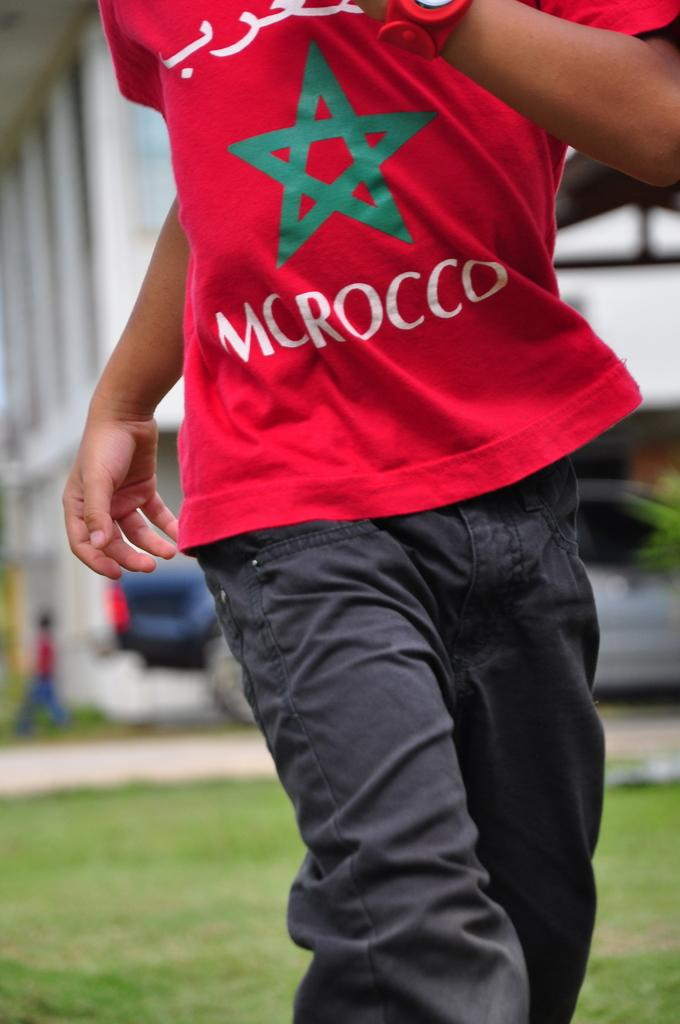Provide a one-sentence caption for the provided image. A guy in a red shirt with a green star and the word Morocco on the front. 